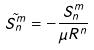Convert formula to latex. <formula><loc_0><loc_0><loc_500><loc_500>\tilde { S _ { n } ^ { m } } = - \frac { S _ { n } ^ { m } } { \mu R ^ { n } }</formula> 